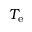<formula> <loc_0><loc_0><loc_500><loc_500>T _ { e }</formula> 